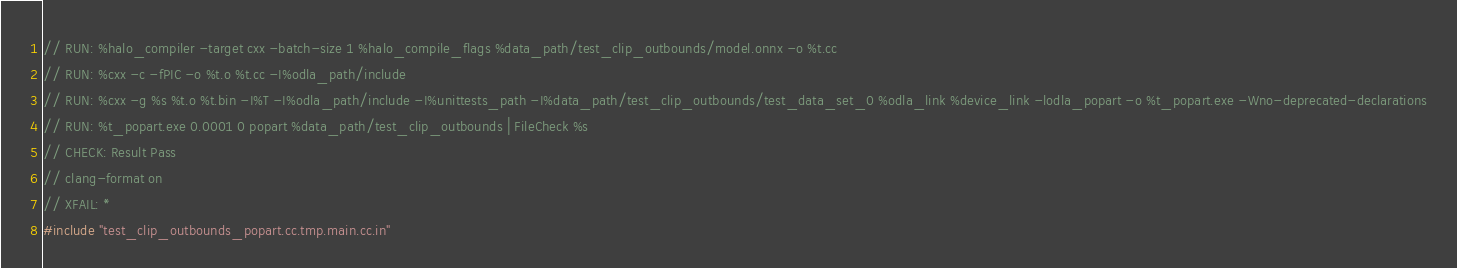<code> <loc_0><loc_0><loc_500><loc_500><_C++_>// RUN: %halo_compiler -target cxx -batch-size 1 %halo_compile_flags %data_path/test_clip_outbounds/model.onnx -o %t.cc
// RUN: %cxx -c -fPIC -o %t.o %t.cc -I%odla_path/include
// RUN: %cxx -g %s %t.o %t.bin -I%T -I%odla_path/include -I%unittests_path -I%data_path/test_clip_outbounds/test_data_set_0 %odla_link %device_link -lodla_popart -o %t_popart.exe -Wno-deprecated-declarations
// RUN: %t_popart.exe 0.0001 0 popart %data_path/test_clip_outbounds | FileCheck %s
// CHECK: Result Pass
// clang-format on
// XFAIL: *
#include "test_clip_outbounds_popart.cc.tmp.main.cc.in"
</code> 